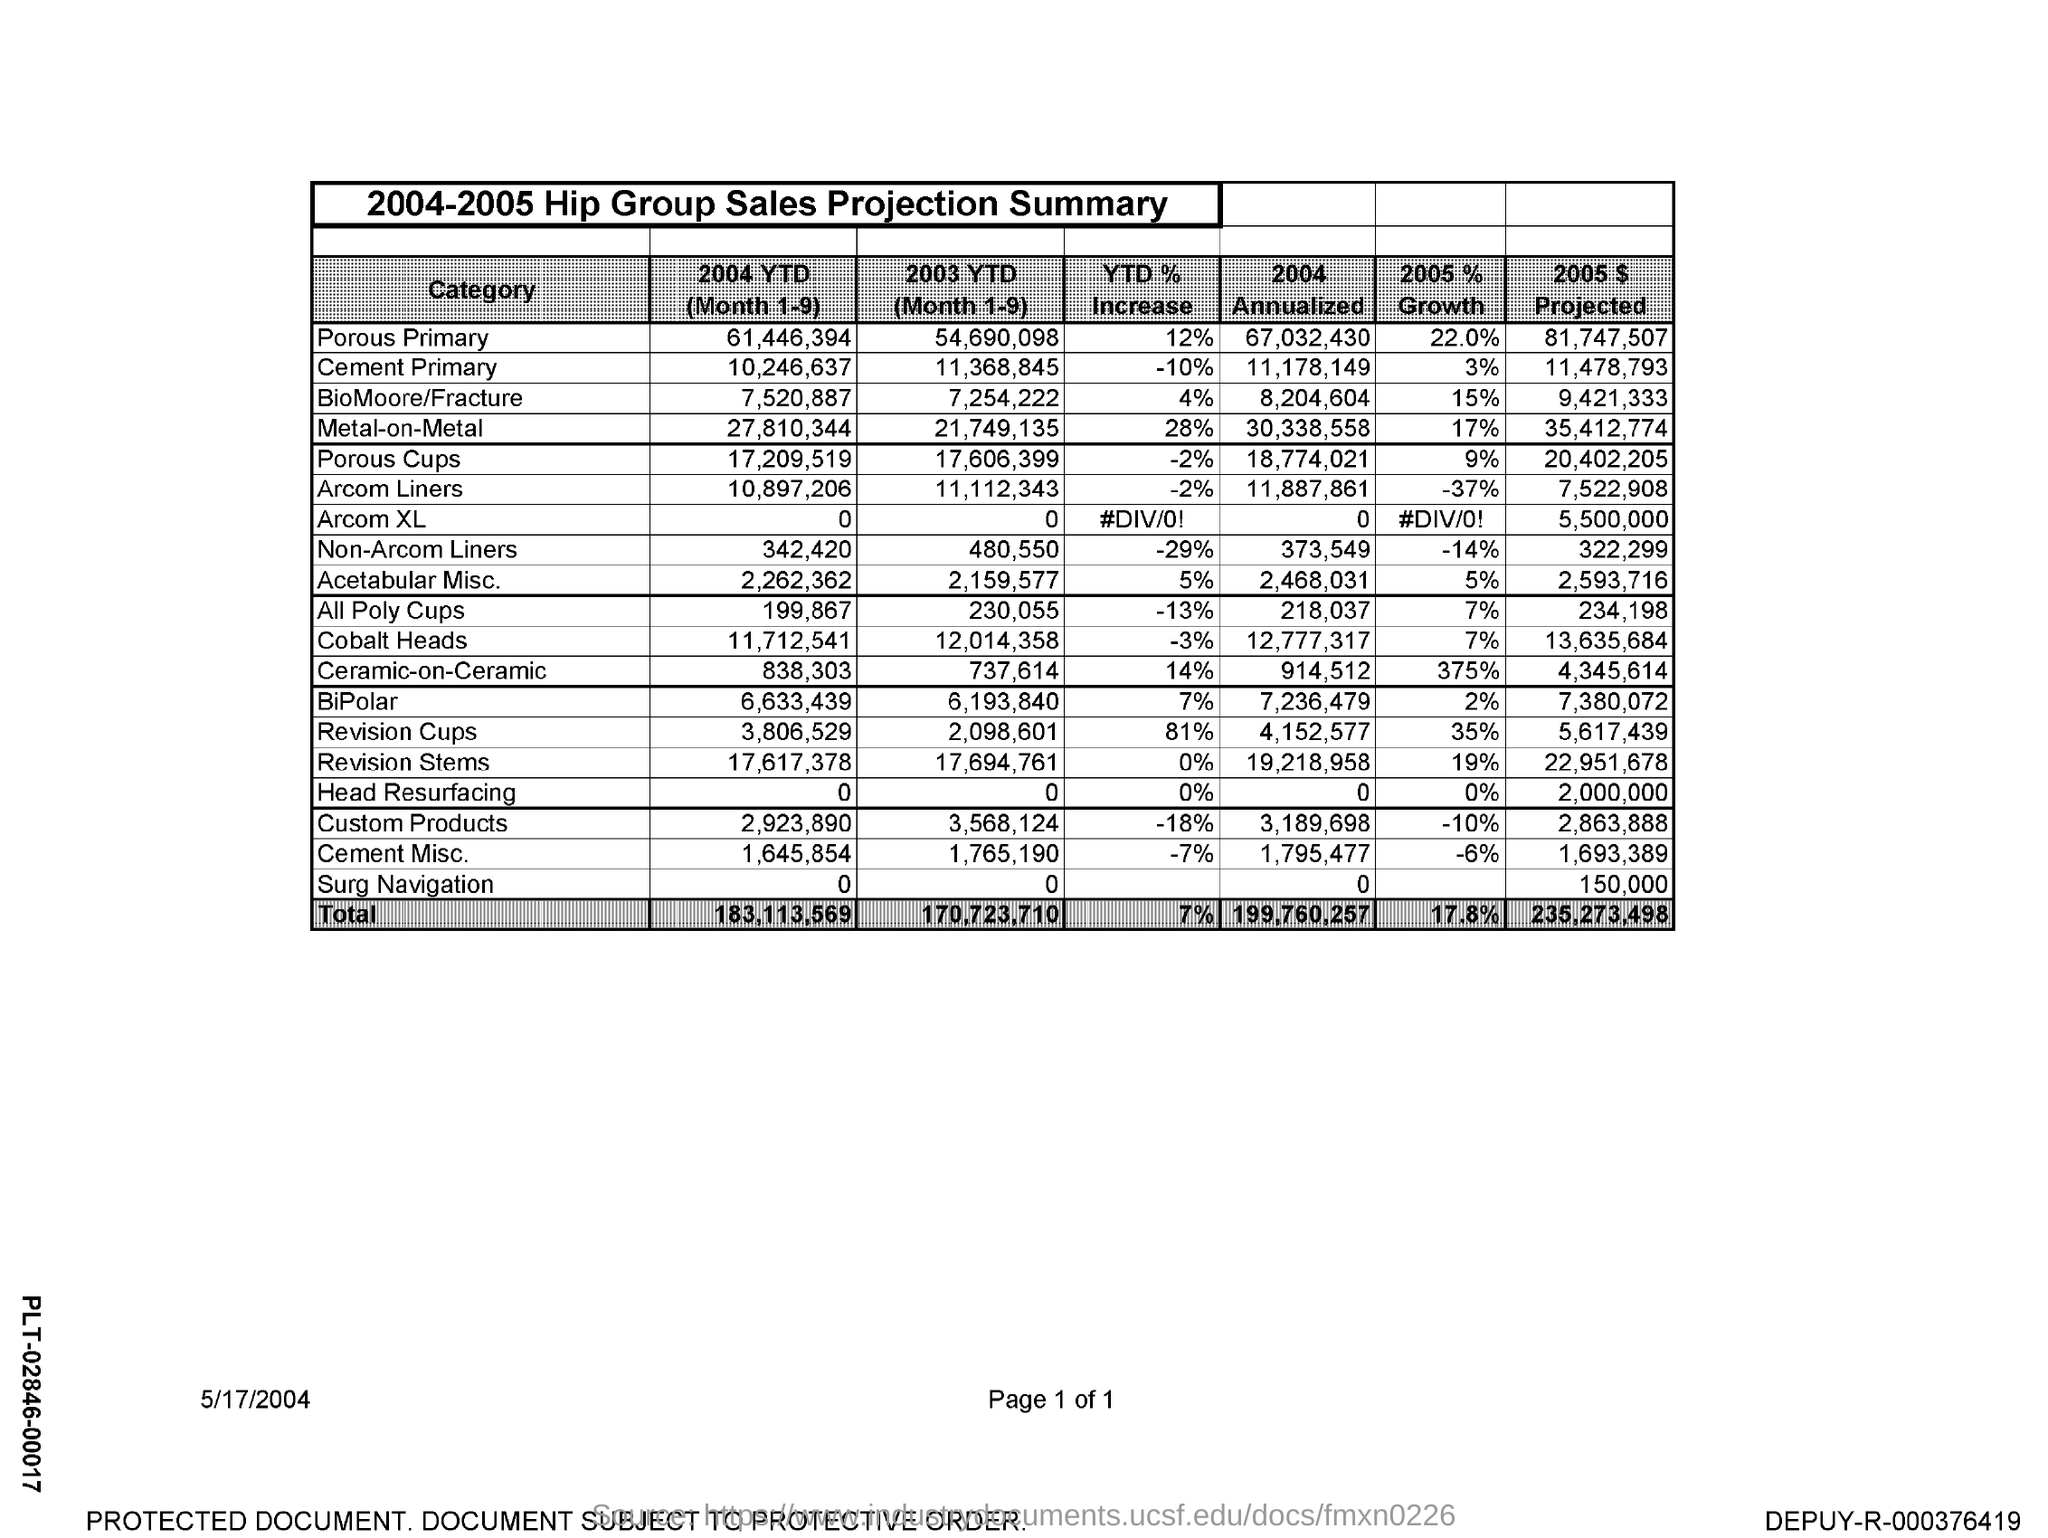What is the date mentioned in the document?
Your response must be concise. 5/17/2004. What is the title of the table?
Provide a short and direct response. 2004-2005 Hip Group Sales Projection Summary. 